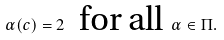<formula> <loc_0><loc_0><loc_500><loc_500>\alpha ( c ) = 2 \ \text { for all } \alpha \in \Pi .</formula> 